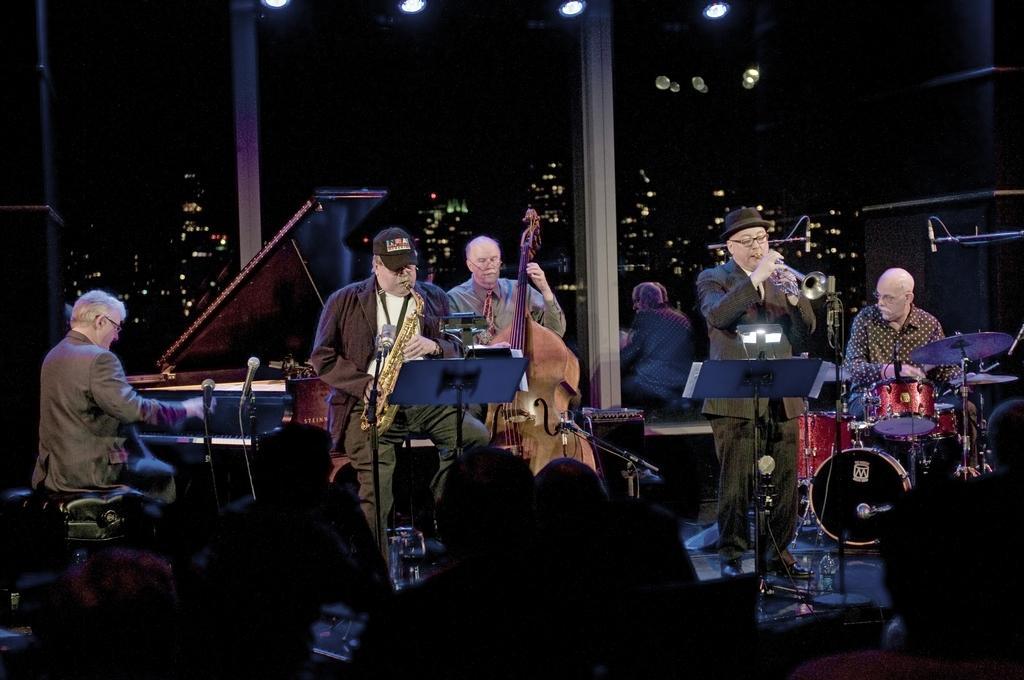In one or two sentences, can you explain what this image depicts? In this picture we can see there are some people standing and some people are sitting and the people are playing some musical instruments. Behind the people there are glass windows and behind the window there are buildings and at the top of the people there are lights. 